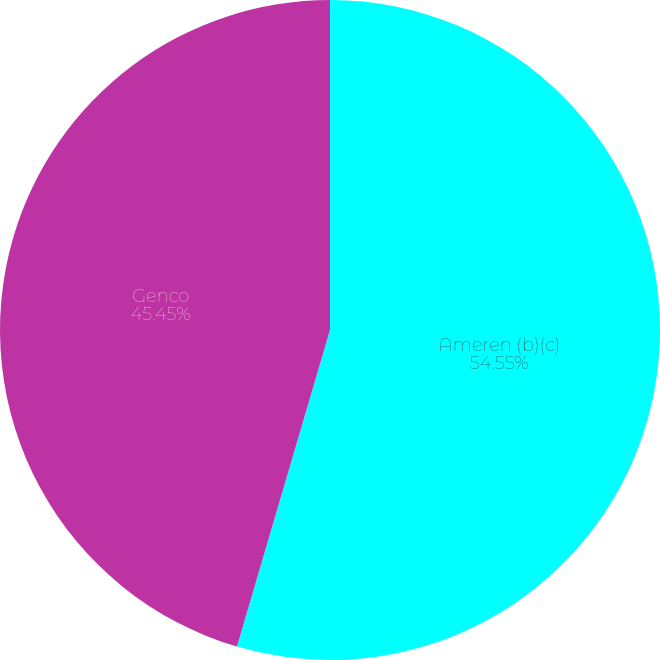Convert chart. <chart><loc_0><loc_0><loc_500><loc_500><pie_chart><fcel>Ameren (b)(c)<fcel>Genco<nl><fcel>54.55%<fcel>45.45%<nl></chart> 